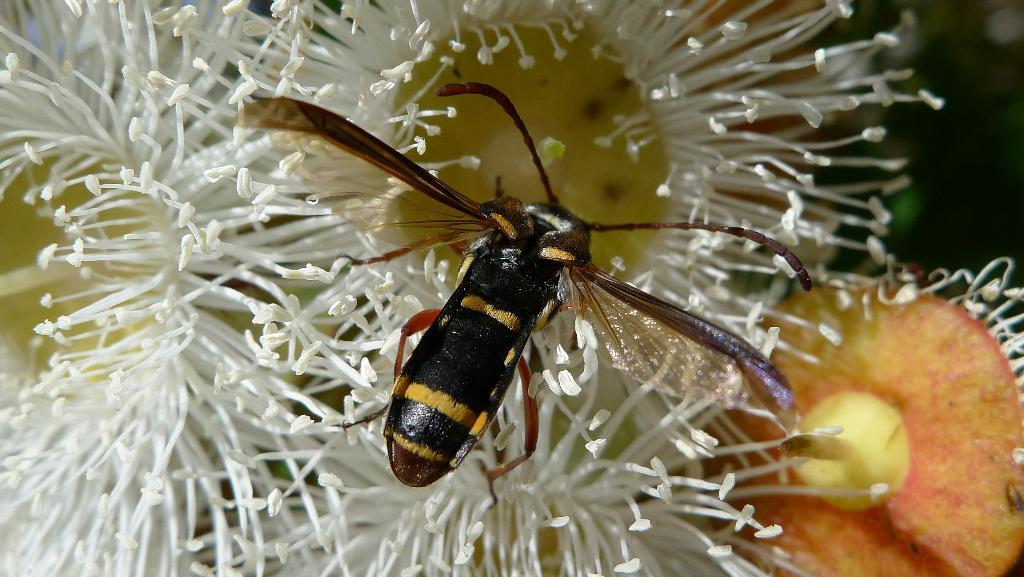What type of creature is in the image? There is an insect in the image. What colors can be seen on the insect? The insect has black, yellow, and brown colors. What can be seen in the background of the image? There are flowers in the background of the image. What colors can be seen on the flowers? The flowers have white, yellow, and orange colors. What type of breakfast is the insect eating in the image? There is no breakfast present in the image, as it features an insect and flowers. 